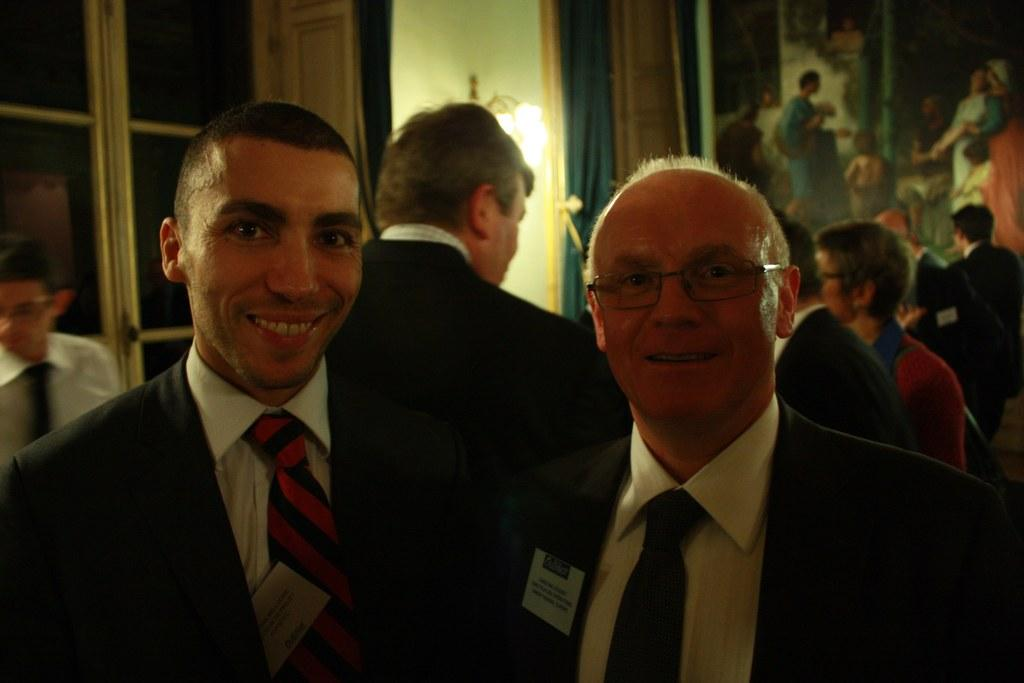What can be seen in the image involving people? There are people standing in the image. What is visible in the background of the image? There are windows and curtains associated with the windows in the background of the image. Can you describe any lighting elements in the image? There is a light fixture in the image. What type of decoration is attached to the wall in the image? There is a photo frame attached to the wall. What type of oven can be seen in the image? There is no oven present in the image. Are there any ghosts visible in the image? There are no ghosts visible in the image. 